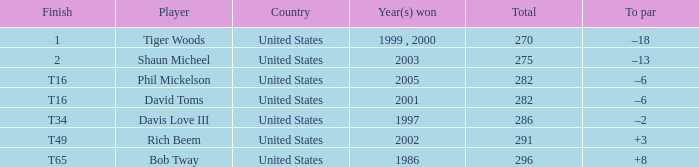In which year(s) did the person who has a total of 291 win? 2002.0. 